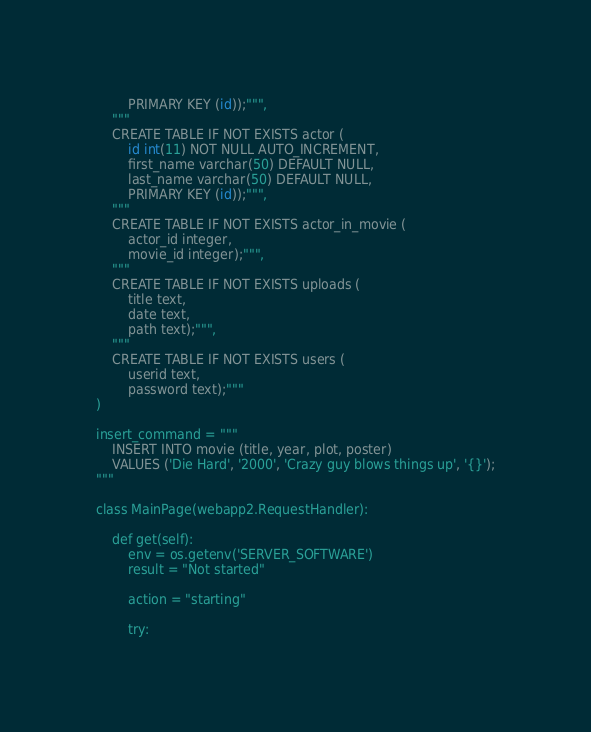Convert code to text. <code><loc_0><loc_0><loc_500><loc_500><_Python_>        PRIMARY KEY (id));""",
    """
    CREATE TABLE IF NOT EXISTS actor (
        id int(11) NOT NULL AUTO_INCREMENT,
        first_name varchar(50) DEFAULT NULL,
        last_name varchar(50) DEFAULT NULL,
        PRIMARY KEY (id));""",
    """
    CREATE TABLE IF NOT EXISTS actor_in_movie (
        actor_id integer,
        movie_id integer);""",
    """
    CREATE TABLE IF NOT EXISTS uploads (
        title text,
        date text,
        path text);""",
    """
    CREATE TABLE IF NOT EXISTS users (
        userid text,
        password text);"""
)

insert_command = """
    INSERT INTO movie (title, year, plot, poster)
    VALUES ('Die Hard', '2000', 'Crazy guy blows things up', '{}');
"""

class MainPage(webapp2.RequestHandler):

    def get(self):
        env = os.getenv('SERVER_SOFTWARE')
        result = "Not started"

        action = "starting"

        try:</code> 